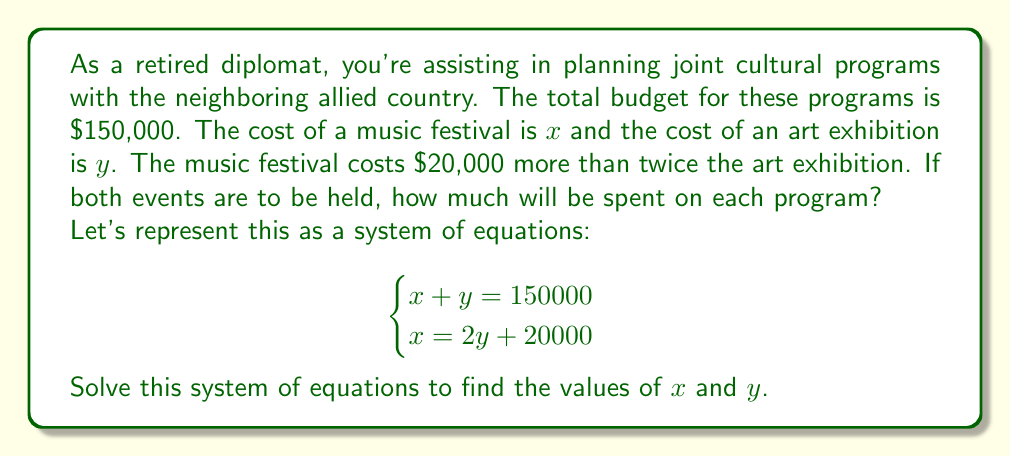Solve this math problem. Let's solve this system of equations step by step:

1) We have two equations:
   $$\begin{cases}
   x + y = 150000 \quad (1)\\
   x = 2y + 20000 \quad (2)
   \end{cases}$$

2) Let's substitute equation (2) into equation (1):
   $$(2y + 20000) + y = 150000$$

3) Simplify:
   $$3y + 20000 = 150000$$

4) Subtract 20000 from both sides:
   $$3y = 130000$$

5) Divide both sides by 3:
   $$y = \frac{130000}{3} = 43333.33$$

6) Round to the nearest whole number (as we're dealing with currency):
   $$y = 43333$$

7) Now that we know $y$, let's find $x$ using equation (2):
   $$x = 2(43333) + 20000 = 106666$$

8) Let's verify our solution using equation (1):
   $$106666 + 43333 = 149999$$

   This is off by 1 due to rounding, which is acceptable for this problem.

Therefore, $x = 106666$ and $y = 43333$.
Answer: Music festival: $106,666; Art exhibition: $43,333 